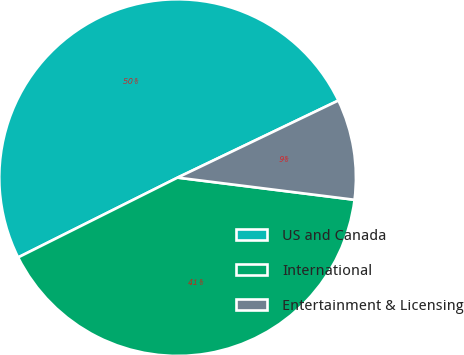Convert chart to OTSL. <chart><loc_0><loc_0><loc_500><loc_500><pie_chart><fcel>US and Canada<fcel>International<fcel>Entertainment & Licensing<nl><fcel>50.27%<fcel>40.63%<fcel>9.1%<nl></chart> 